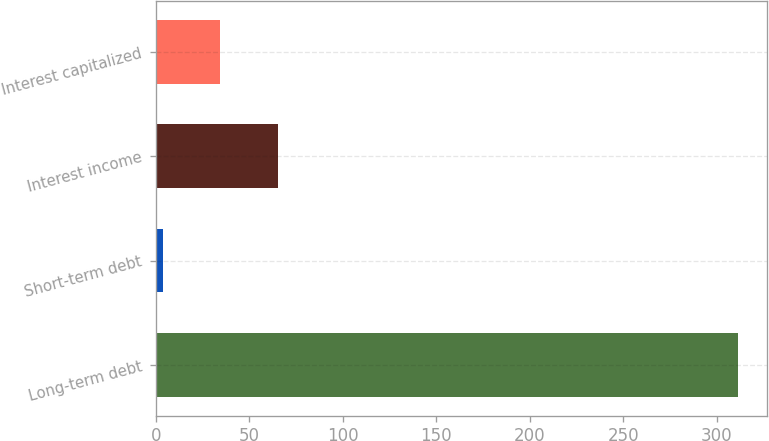<chart> <loc_0><loc_0><loc_500><loc_500><bar_chart><fcel>Long-term debt<fcel>Short-term debt<fcel>Interest income<fcel>Interest capitalized<nl><fcel>311.5<fcel>3.8<fcel>65.34<fcel>34.57<nl></chart> 